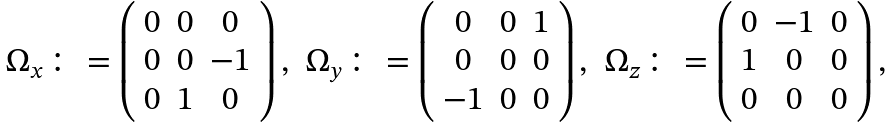<formula> <loc_0><loc_0><loc_500><loc_500>\begin{array} { c c c } \Omega _ { x } \colon = \left ( \begin{array} { c c c } 0 & 0 & 0 \\ 0 & 0 & - 1 \\ 0 & 1 & 0 \end{array} \right ) , & \Omega _ { y } \colon = \left ( \begin{array} { c c c } 0 & 0 & 1 \\ 0 & 0 & 0 \\ - 1 & 0 & 0 \end{array} \right ) , & \Omega _ { z } \colon = \left ( \begin{array} { c c c } 0 & - 1 & 0 \\ 1 & 0 & 0 \\ 0 & 0 & 0 \end{array} \right ) , \end{array}</formula> 